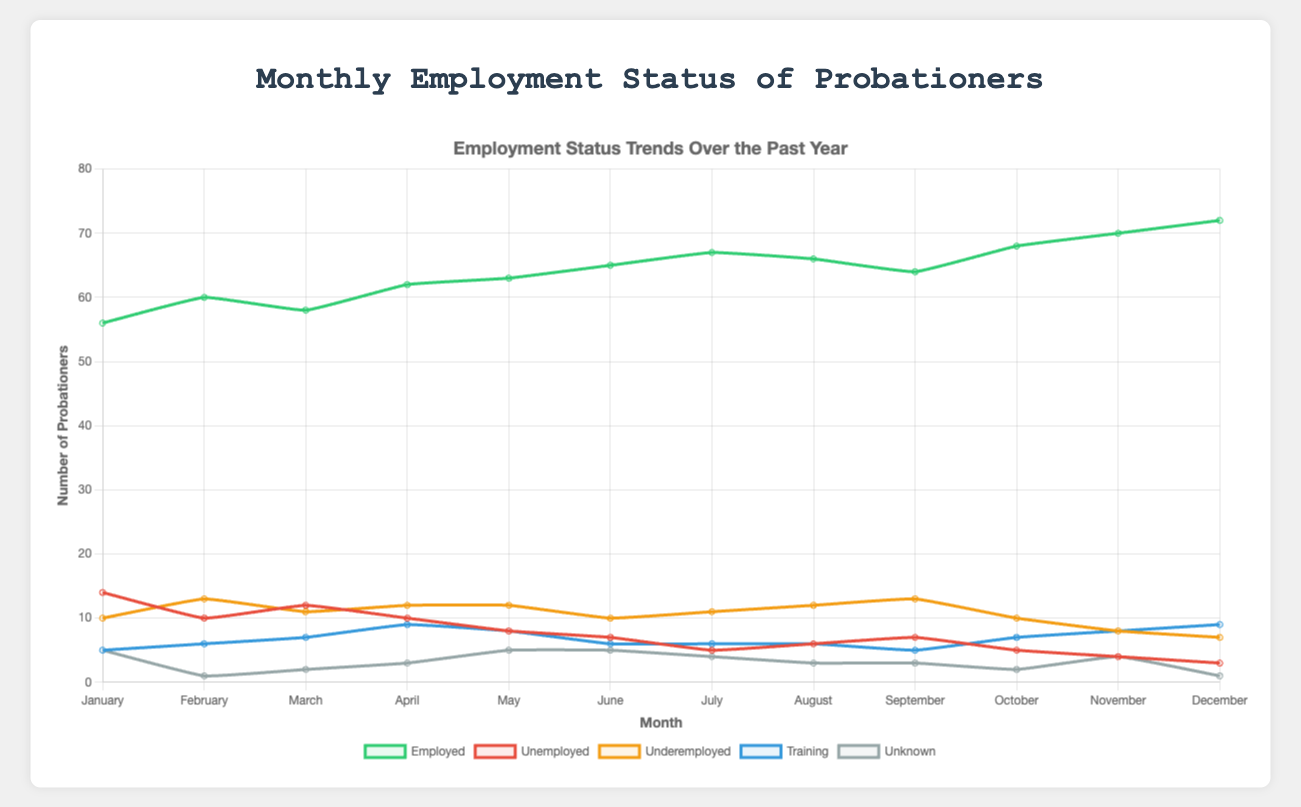What is the difference in the number of employed probationers between January and December? To find the difference, subtract the number of employed probationers in January from that in December: 72 (December) - 56 (January) = 16
Answer: 16 Which month had the highest number of unemployed probationers? By visually inspecting the lines marked for 'Unemployed' in red color, January had the highest number at 14
Answer: January What was the average number of probationers in training over the year? To find the average, sum the number of probationers in training for each month and divide by 12: (5 + 6 + 7 + 9 + 8 + 6 + 6 + 6 + 5 + 7 + 8 + 9) / 12 = 7
Answer: 7 Which category showed the most significant change in values from January to December? By visually comparing the dataset lines' changes from January to December, the 'Employed' category in green shows the most significant increase, from 56 to 72
Answer: Employed In which month were the number of underemployed probationers at its peak? Observing the orange line for 'Underemployed,' the peak is in February and September at 13
Answer: February and September What is the range of 'unknown' statuses reported over the year? To find the range, identify the maximum and minimum values of the 'unknown' category from all months and then subtract them. Maximum = 5 in January, Minimum = 1 in February and December, so Range = 5 - 1 = 4
Answer: 4 In which month did the number of employed probationers first exceed 60? Looking at the green line for 'Employed,' it first crosses 60 in April, with a value of 62
Answer: April Which month witnessed the lowest number of underemployed probationers? Analyzing the orange line for 'Underemployed,' it's evident that December had the lowest number at 7
Answer: December Compare the number of training probationers in April and September. Is it the same, more, or less in September compared to April? By comparing the blue line for 'Training' in April (9) and September (5), it is evident that it is less in September compared to April
Answer: Less How many probationers were either underemployed or in training in July? Add the values for 'Underemployed' (11) and 'Training' (6) for July: 11 + 6 = 17
Answer: 17 